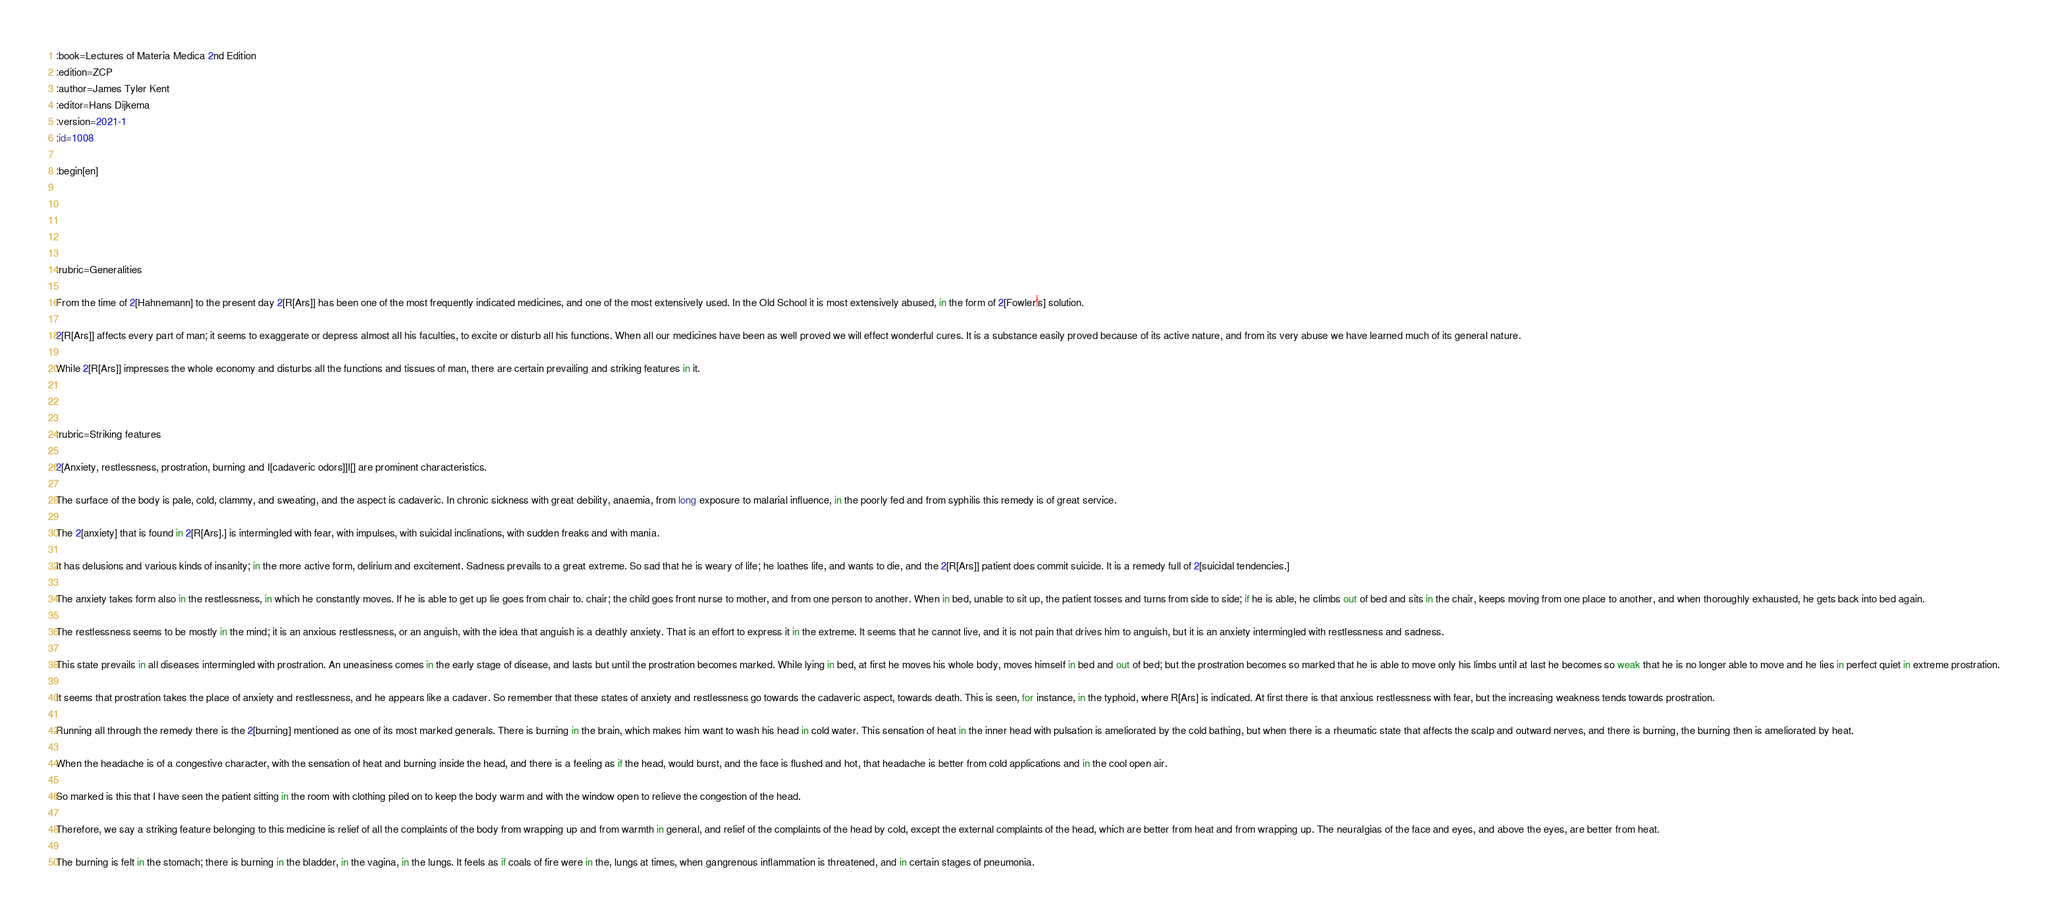<code> <loc_0><loc_0><loc_500><loc_500><_ObjectiveC_>:book=Lectures of Materia Medica 2nd Edition
:edition=ZCP
:author=James Tyler Kent
:editor=Hans Dijkema
:version=2021-1
:id=1008

:begin[en]





:rubric=Generalities

From the time of 2[Hahnemann] to the present day 2[R[Ars]] has been one of the most frequently indicated medicines, and one of the most extensively used. In the Old School it is most extensively abused, in the form of 2[Fowler's] solution.

2[R[Ars]] affects every part of man; it seems to exaggerate or depress almost all his faculties, to excite or disturb all his functions. When all our medicines have been as well proved we will effect wonderful cures. It is a substance easily proved because of its active nature, and from its very abuse we have learned much of its general nature.

While 2[R[Ars]] impresses the whole economy and disturbs all the functions and tissues of man, there are certain prevailing and striking features in it.



:rubric=Striking features

2[Anxiety, restlessness, prostration, burning and I[cadaveric odors]]I[] are prominent characteristics.

The surface of the body is pale, cold, clammy, and sweating, and the aspect is cadaveric. In chronic sickness with great debility, anaemia, from long exposure to malarial influence, in the poorly fed and from syphilis this remedy is of great service.

The 2[anxiety] that is found in 2[R[Ars].] is intermingled with fear, with impulses, with suicidal inclinations, with sudden freaks and with mania.

It has delusions and various kinds of insanity; in the more active form, delirium and excitement. Sadness prevails to a great extreme. So sad that he is weary of life; he loathes life, and wants to die, and the 2[R[Ars]] patient does commit suicide. It is a remedy full of 2[suicidal tendencies.]

The anxiety takes form also in the restlessness, in which he constantly moves. If he is able to get up lie goes from chair to. chair; the child goes front nurse to mother, and from one person to another. When in bed, unable to sit up, the patient tosses and turns from side to side; if he is able, he climbs out of bed and sits in the chair, keeps moving from one place to another, and when thoroughly exhausted, he gets back into bed again.

The restlessness seems to be mostly in the mind; it is an anxious restlessness, or an anguish, with the idea that anguish is a deathly anxiety. That is an effort to express it in the extreme. It seems that he cannot live, and it is not pain that drives him to anguish, but it is an anxiety intermingled with restlessness and sadness.

This state prevails in all diseases intermingled with prostration. An uneasiness comes in the early stage of disease, and lasts but until the prostration becomes marked. While lying in bed, at first he moves his whole body, moves himself in bed and out of bed; but the prostration becomes so marked that he is able to move only his limbs until at last he becomes so weak that he is no longer able to move and he lies in perfect quiet in extreme prostration.

It seems that prostration takes the place of anxiety and restlessness, and he appears like a cadaver. So remember that these states of anxiety and restlessness go towards the cadaveric aspect, towards death. This is seen, for instance, in the typhoid, where R[Ars] is indicated. At first there is that anxious restlessness with fear, but the increasing weakness tends towards prostration.

Running all through the remedy there is the 2[burning] mentioned as one of its most marked generals. There is burning in the brain, which makes him want to wash his head in cold water. This sensation of heat in the inner head with pulsation is ameliorated by the cold bathing, but when there is a rheumatic state that affects the scalp and outward nerves, and there is burning, the burning then is ameliorated by heat.

When the headache is of a congestive character, with the sensation of heat and burning inside the head, and there is a feeling as if the head, would burst, and the face is flushed and hot, that headache is better from cold applications and in the cool open air.

So marked is this that I have seen the patient sitting in the room with clothing piled on to keep the body warm and with the window open to relieve the congestion of the head.

Therefore, we say a striking feature belonging to this medicine is relief of all the complaints of the body from wrapping up and from warmth in general, and relief of the complaints of the head by cold, except the external complaints of the head, which are better from heat and from wrapping up. The neuralgias of the face and eyes, and above the eyes, are better from heat.

The burning is felt in the stomach; there is burning in the bladder, in the vagina, in the lungs. It feels as if coals of fire were in the, lungs at times, when gangrenous inflammation is threatened, and in certain stages of pneumonia.
</code> 